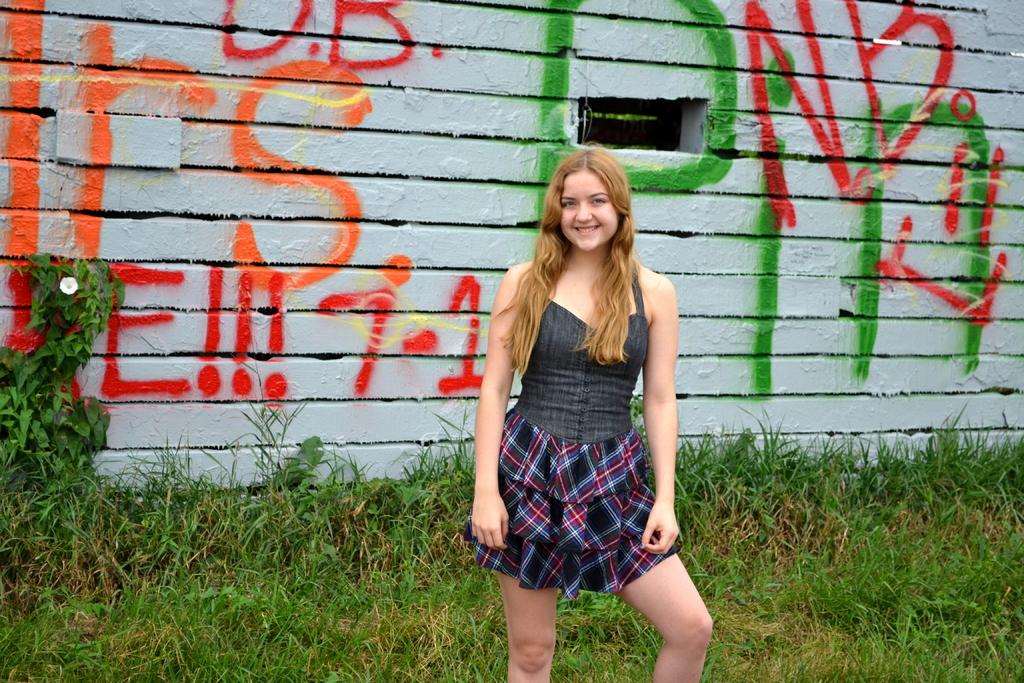Who is the main subject in the image? There is a lady in the center of the image. What is the lady doing in the image? The lady is standing and smiling. What can be seen in the background of the image? There is a wall in the background of the image, and there is graffiti on the wall. What type of ground is visible at the bottom of the image? There is grass at the bottom of the image. How many zebras are visible in the image? There are no zebras present in the image. What breed of dogs can be seen playing with the lady in the image? There are no dogs present in the image; the lady is standing alone and smiling. 